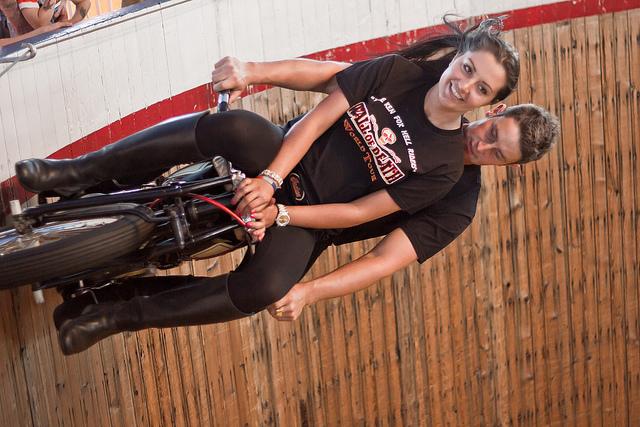Is that a scooter?
Quick response, please. No. How was the picture taken?
Concise answer only. Sideways. What are they sitting on?
Give a very brief answer. Motorcycle. Is this man a hipster skater?
Quick response, please. No. What does the shirt say?
Answer briefly. Wall of death. 